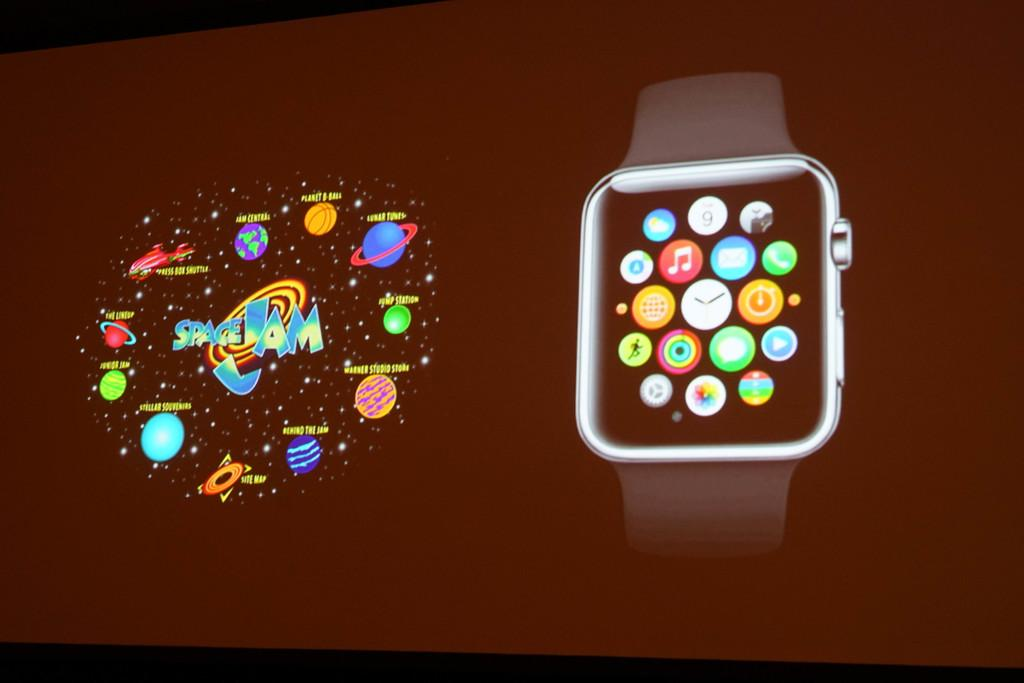<image>
Offer a succinct explanation of the picture presented. Close up of a Space Jam game on a wrist watch phone. 